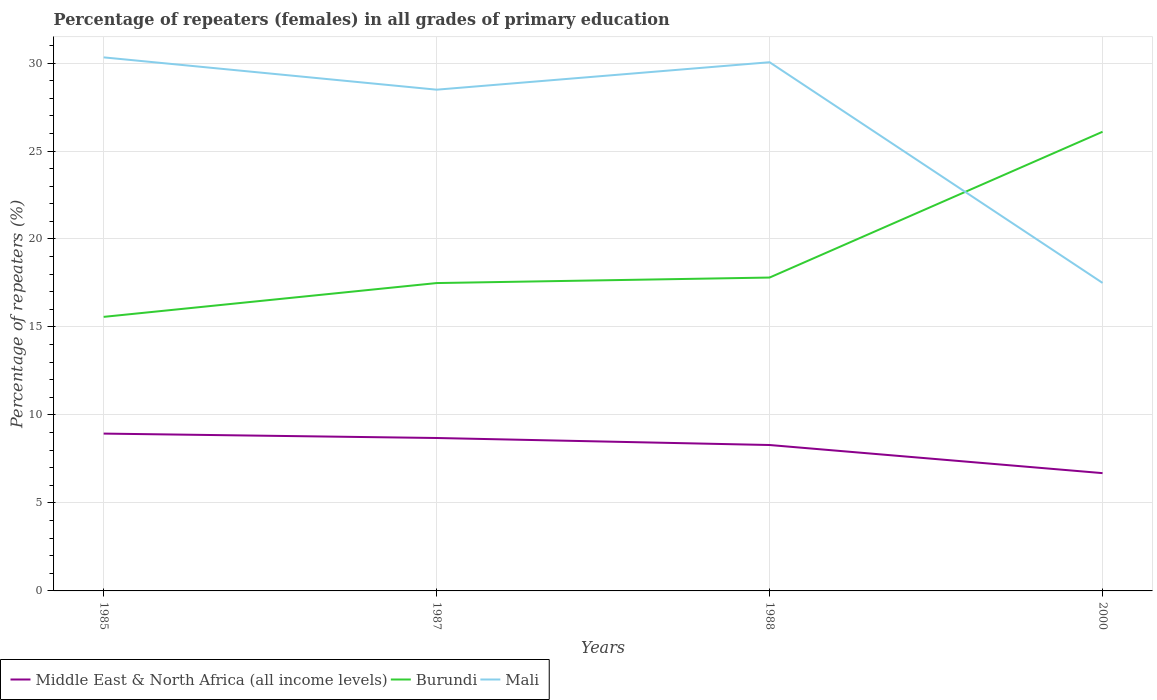Is the number of lines equal to the number of legend labels?
Offer a very short reply. Yes. Across all years, what is the maximum percentage of repeaters (females) in Middle East & North Africa (all income levels)?
Offer a very short reply. 6.69. In which year was the percentage of repeaters (females) in Mali maximum?
Your answer should be very brief. 2000. What is the total percentage of repeaters (females) in Burundi in the graph?
Your answer should be compact. -10.52. What is the difference between the highest and the second highest percentage of repeaters (females) in Mali?
Give a very brief answer. 12.82. How many years are there in the graph?
Your response must be concise. 4. Does the graph contain any zero values?
Keep it short and to the point. No. Where does the legend appear in the graph?
Offer a terse response. Bottom left. What is the title of the graph?
Offer a terse response. Percentage of repeaters (females) in all grades of primary education. What is the label or title of the Y-axis?
Offer a very short reply. Percentage of repeaters (%). What is the Percentage of repeaters (%) in Middle East & North Africa (all income levels) in 1985?
Your answer should be very brief. 8.94. What is the Percentage of repeaters (%) of Burundi in 1985?
Provide a short and direct response. 15.57. What is the Percentage of repeaters (%) of Mali in 1985?
Your answer should be very brief. 30.32. What is the Percentage of repeaters (%) in Middle East & North Africa (all income levels) in 1987?
Your answer should be very brief. 8.69. What is the Percentage of repeaters (%) in Burundi in 1987?
Your response must be concise. 17.5. What is the Percentage of repeaters (%) in Mali in 1987?
Make the answer very short. 28.49. What is the Percentage of repeaters (%) of Middle East & North Africa (all income levels) in 1988?
Offer a very short reply. 8.29. What is the Percentage of repeaters (%) of Burundi in 1988?
Offer a terse response. 17.81. What is the Percentage of repeaters (%) in Mali in 1988?
Make the answer very short. 30.05. What is the Percentage of repeaters (%) of Middle East & North Africa (all income levels) in 2000?
Provide a succinct answer. 6.69. What is the Percentage of repeaters (%) of Burundi in 2000?
Keep it short and to the point. 26.09. What is the Percentage of repeaters (%) in Mali in 2000?
Provide a short and direct response. 17.5. Across all years, what is the maximum Percentage of repeaters (%) in Middle East & North Africa (all income levels)?
Offer a very short reply. 8.94. Across all years, what is the maximum Percentage of repeaters (%) of Burundi?
Your response must be concise. 26.09. Across all years, what is the maximum Percentage of repeaters (%) in Mali?
Ensure brevity in your answer.  30.32. Across all years, what is the minimum Percentage of repeaters (%) in Middle East & North Africa (all income levels)?
Your response must be concise. 6.69. Across all years, what is the minimum Percentage of repeaters (%) of Burundi?
Your answer should be compact. 15.57. Across all years, what is the minimum Percentage of repeaters (%) in Mali?
Provide a short and direct response. 17.5. What is the total Percentage of repeaters (%) of Middle East & North Africa (all income levels) in the graph?
Ensure brevity in your answer.  32.62. What is the total Percentage of repeaters (%) of Burundi in the graph?
Keep it short and to the point. 76.97. What is the total Percentage of repeaters (%) of Mali in the graph?
Ensure brevity in your answer.  106.36. What is the difference between the Percentage of repeaters (%) in Middle East & North Africa (all income levels) in 1985 and that in 1987?
Offer a very short reply. 0.25. What is the difference between the Percentage of repeaters (%) of Burundi in 1985 and that in 1987?
Offer a very short reply. -1.92. What is the difference between the Percentage of repeaters (%) in Mali in 1985 and that in 1987?
Your response must be concise. 1.84. What is the difference between the Percentage of repeaters (%) of Middle East & North Africa (all income levels) in 1985 and that in 1988?
Provide a succinct answer. 0.65. What is the difference between the Percentage of repeaters (%) in Burundi in 1985 and that in 1988?
Your answer should be very brief. -2.23. What is the difference between the Percentage of repeaters (%) in Mali in 1985 and that in 1988?
Provide a short and direct response. 0.28. What is the difference between the Percentage of repeaters (%) in Middle East & North Africa (all income levels) in 1985 and that in 2000?
Make the answer very short. 2.25. What is the difference between the Percentage of repeaters (%) of Burundi in 1985 and that in 2000?
Provide a short and direct response. -10.52. What is the difference between the Percentage of repeaters (%) of Mali in 1985 and that in 2000?
Provide a succinct answer. 12.82. What is the difference between the Percentage of repeaters (%) in Middle East & North Africa (all income levels) in 1987 and that in 1988?
Provide a succinct answer. 0.4. What is the difference between the Percentage of repeaters (%) of Burundi in 1987 and that in 1988?
Offer a very short reply. -0.31. What is the difference between the Percentage of repeaters (%) in Mali in 1987 and that in 1988?
Your answer should be very brief. -1.56. What is the difference between the Percentage of repeaters (%) in Middle East & North Africa (all income levels) in 1987 and that in 2000?
Offer a terse response. 2. What is the difference between the Percentage of repeaters (%) of Burundi in 1987 and that in 2000?
Your answer should be compact. -8.6. What is the difference between the Percentage of repeaters (%) of Mali in 1987 and that in 2000?
Provide a short and direct response. 10.98. What is the difference between the Percentage of repeaters (%) in Middle East & North Africa (all income levels) in 1988 and that in 2000?
Keep it short and to the point. 1.6. What is the difference between the Percentage of repeaters (%) in Burundi in 1988 and that in 2000?
Provide a short and direct response. -8.29. What is the difference between the Percentage of repeaters (%) of Mali in 1988 and that in 2000?
Make the answer very short. 12.54. What is the difference between the Percentage of repeaters (%) of Middle East & North Africa (all income levels) in 1985 and the Percentage of repeaters (%) of Burundi in 1987?
Your response must be concise. -8.55. What is the difference between the Percentage of repeaters (%) in Middle East & North Africa (all income levels) in 1985 and the Percentage of repeaters (%) in Mali in 1987?
Your answer should be very brief. -19.54. What is the difference between the Percentage of repeaters (%) in Burundi in 1985 and the Percentage of repeaters (%) in Mali in 1987?
Provide a succinct answer. -12.91. What is the difference between the Percentage of repeaters (%) in Middle East & North Africa (all income levels) in 1985 and the Percentage of repeaters (%) in Burundi in 1988?
Give a very brief answer. -8.87. What is the difference between the Percentage of repeaters (%) of Middle East & North Africa (all income levels) in 1985 and the Percentage of repeaters (%) of Mali in 1988?
Keep it short and to the point. -21.1. What is the difference between the Percentage of repeaters (%) of Burundi in 1985 and the Percentage of repeaters (%) of Mali in 1988?
Give a very brief answer. -14.47. What is the difference between the Percentage of repeaters (%) in Middle East & North Africa (all income levels) in 1985 and the Percentage of repeaters (%) in Burundi in 2000?
Keep it short and to the point. -17.15. What is the difference between the Percentage of repeaters (%) of Middle East & North Africa (all income levels) in 1985 and the Percentage of repeaters (%) of Mali in 2000?
Offer a very short reply. -8.56. What is the difference between the Percentage of repeaters (%) in Burundi in 1985 and the Percentage of repeaters (%) in Mali in 2000?
Give a very brief answer. -1.93. What is the difference between the Percentage of repeaters (%) of Middle East & North Africa (all income levels) in 1987 and the Percentage of repeaters (%) of Burundi in 1988?
Your response must be concise. -9.12. What is the difference between the Percentage of repeaters (%) of Middle East & North Africa (all income levels) in 1987 and the Percentage of repeaters (%) of Mali in 1988?
Ensure brevity in your answer.  -21.36. What is the difference between the Percentage of repeaters (%) in Burundi in 1987 and the Percentage of repeaters (%) in Mali in 1988?
Offer a terse response. -12.55. What is the difference between the Percentage of repeaters (%) in Middle East & North Africa (all income levels) in 1987 and the Percentage of repeaters (%) in Burundi in 2000?
Provide a succinct answer. -17.4. What is the difference between the Percentage of repeaters (%) of Middle East & North Africa (all income levels) in 1987 and the Percentage of repeaters (%) of Mali in 2000?
Provide a short and direct response. -8.81. What is the difference between the Percentage of repeaters (%) in Burundi in 1987 and the Percentage of repeaters (%) in Mali in 2000?
Offer a very short reply. -0.01. What is the difference between the Percentage of repeaters (%) of Middle East & North Africa (all income levels) in 1988 and the Percentage of repeaters (%) of Burundi in 2000?
Provide a succinct answer. -17.8. What is the difference between the Percentage of repeaters (%) in Middle East & North Africa (all income levels) in 1988 and the Percentage of repeaters (%) in Mali in 2000?
Offer a terse response. -9.21. What is the difference between the Percentage of repeaters (%) in Burundi in 1988 and the Percentage of repeaters (%) in Mali in 2000?
Offer a terse response. 0.3. What is the average Percentage of repeaters (%) in Middle East & North Africa (all income levels) per year?
Ensure brevity in your answer.  8.15. What is the average Percentage of repeaters (%) in Burundi per year?
Give a very brief answer. 19.24. What is the average Percentage of repeaters (%) in Mali per year?
Make the answer very short. 26.59. In the year 1985, what is the difference between the Percentage of repeaters (%) in Middle East & North Africa (all income levels) and Percentage of repeaters (%) in Burundi?
Provide a succinct answer. -6.63. In the year 1985, what is the difference between the Percentage of repeaters (%) of Middle East & North Africa (all income levels) and Percentage of repeaters (%) of Mali?
Offer a terse response. -21.38. In the year 1985, what is the difference between the Percentage of repeaters (%) in Burundi and Percentage of repeaters (%) in Mali?
Provide a succinct answer. -14.75. In the year 1987, what is the difference between the Percentage of repeaters (%) of Middle East & North Africa (all income levels) and Percentage of repeaters (%) of Burundi?
Your response must be concise. -8.8. In the year 1987, what is the difference between the Percentage of repeaters (%) of Middle East & North Africa (all income levels) and Percentage of repeaters (%) of Mali?
Provide a short and direct response. -19.79. In the year 1987, what is the difference between the Percentage of repeaters (%) in Burundi and Percentage of repeaters (%) in Mali?
Provide a succinct answer. -10.99. In the year 1988, what is the difference between the Percentage of repeaters (%) of Middle East & North Africa (all income levels) and Percentage of repeaters (%) of Burundi?
Your response must be concise. -9.52. In the year 1988, what is the difference between the Percentage of repeaters (%) of Middle East & North Africa (all income levels) and Percentage of repeaters (%) of Mali?
Your answer should be compact. -21.75. In the year 1988, what is the difference between the Percentage of repeaters (%) of Burundi and Percentage of repeaters (%) of Mali?
Your response must be concise. -12.24. In the year 2000, what is the difference between the Percentage of repeaters (%) of Middle East & North Africa (all income levels) and Percentage of repeaters (%) of Burundi?
Your answer should be compact. -19.4. In the year 2000, what is the difference between the Percentage of repeaters (%) of Middle East & North Africa (all income levels) and Percentage of repeaters (%) of Mali?
Ensure brevity in your answer.  -10.81. In the year 2000, what is the difference between the Percentage of repeaters (%) in Burundi and Percentage of repeaters (%) in Mali?
Offer a terse response. 8.59. What is the ratio of the Percentage of repeaters (%) of Middle East & North Africa (all income levels) in 1985 to that in 1987?
Provide a succinct answer. 1.03. What is the ratio of the Percentage of repeaters (%) in Burundi in 1985 to that in 1987?
Keep it short and to the point. 0.89. What is the ratio of the Percentage of repeaters (%) in Mali in 1985 to that in 1987?
Provide a succinct answer. 1.06. What is the ratio of the Percentage of repeaters (%) of Middle East & North Africa (all income levels) in 1985 to that in 1988?
Keep it short and to the point. 1.08. What is the ratio of the Percentage of repeaters (%) in Burundi in 1985 to that in 1988?
Offer a very short reply. 0.87. What is the ratio of the Percentage of repeaters (%) in Mali in 1985 to that in 1988?
Offer a very short reply. 1.01. What is the ratio of the Percentage of repeaters (%) of Middle East & North Africa (all income levels) in 1985 to that in 2000?
Your response must be concise. 1.34. What is the ratio of the Percentage of repeaters (%) in Burundi in 1985 to that in 2000?
Provide a short and direct response. 0.6. What is the ratio of the Percentage of repeaters (%) in Mali in 1985 to that in 2000?
Offer a very short reply. 1.73. What is the ratio of the Percentage of repeaters (%) of Middle East & North Africa (all income levels) in 1987 to that in 1988?
Offer a very short reply. 1.05. What is the ratio of the Percentage of repeaters (%) in Burundi in 1987 to that in 1988?
Your answer should be very brief. 0.98. What is the ratio of the Percentage of repeaters (%) of Mali in 1987 to that in 1988?
Offer a terse response. 0.95. What is the ratio of the Percentage of repeaters (%) of Middle East & North Africa (all income levels) in 1987 to that in 2000?
Provide a short and direct response. 1.3. What is the ratio of the Percentage of repeaters (%) of Burundi in 1987 to that in 2000?
Make the answer very short. 0.67. What is the ratio of the Percentage of repeaters (%) of Mali in 1987 to that in 2000?
Your response must be concise. 1.63. What is the ratio of the Percentage of repeaters (%) of Middle East & North Africa (all income levels) in 1988 to that in 2000?
Your answer should be very brief. 1.24. What is the ratio of the Percentage of repeaters (%) of Burundi in 1988 to that in 2000?
Give a very brief answer. 0.68. What is the ratio of the Percentage of repeaters (%) in Mali in 1988 to that in 2000?
Provide a short and direct response. 1.72. What is the difference between the highest and the second highest Percentage of repeaters (%) in Middle East & North Africa (all income levels)?
Ensure brevity in your answer.  0.25. What is the difference between the highest and the second highest Percentage of repeaters (%) of Burundi?
Offer a terse response. 8.29. What is the difference between the highest and the second highest Percentage of repeaters (%) in Mali?
Your answer should be compact. 0.28. What is the difference between the highest and the lowest Percentage of repeaters (%) of Middle East & North Africa (all income levels)?
Offer a terse response. 2.25. What is the difference between the highest and the lowest Percentage of repeaters (%) in Burundi?
Provide a short and direct response. 10.52. What is the difference between the highest and the lowest Percentage of repeaters (%) of Mali?
Provide a short and direct response. 12.82. 